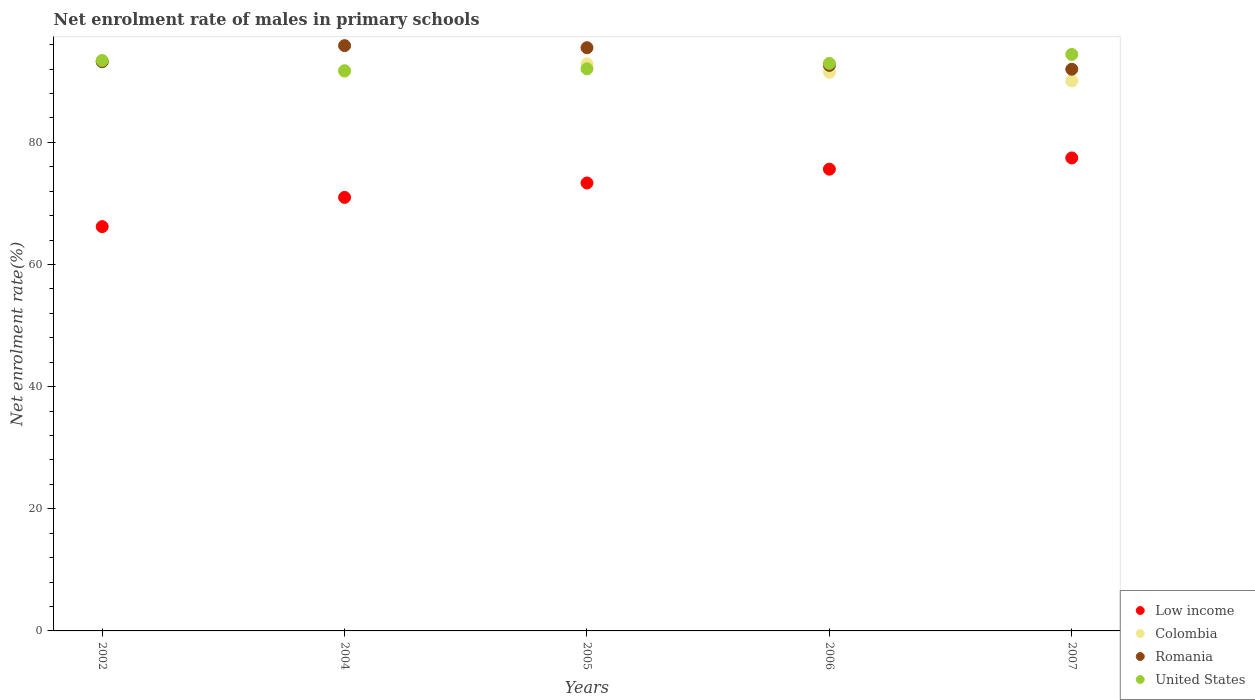Is the number of dotlines equal to the number of legend labels?
Make the answer very short. Yes. What is the net enrolment rate of males in primary schools in United States in 2007?
Offer a very short reply. 94.41. Across all years, what is the maximum net enrolment rate of males in primary schools in Colombia?
Offer a very short reply. 93.23. Across all years, what is the minimum net enrolment rate of males in primary schools in Colombia?
Keep it short and to the point. 90.07. In which year was the net enrolment rate of males in primary schools in Romania maximum?
Your response must be concise. 2004. What is the total net enrolment rate of males in primary schools in Low income in the graph?
Keep it short and to the point. 363.62. What is the difference between the net enrolment rate of males in primary schools in United States in 2004 and that in 2006?
Keep it short and to the point. -1.2. What is the difference between the net enrolment rate of males in primary schools in Colombia in 2004 and the net enrolment rate of males in primary schools in Romania in 2005?
Offer a very short reply. -3.9. What is the average net enrolment rate of males in primary schools in United States per year?
Your response must be concise. 92.91. In the year 2002, what is the difference between the net enrolment rate of males in primary schools in Colombia and net enrolment rate of males in primary schools in United States?
Make the answer very short. -0.18. In how many years, is the net enrolment rate of males in primary schools in United States greater than 12 %?
Keep it short and to the point. 5. What is the ratio of the net enrolment rate of males in primary schools in United States in 2002 to that in 2007?
Your response must be concise. 0.99. Is the net enrolment rate of males in primary schools in Romania in 2005 less than that in 2006?
Make the answer very short. No. What is the difference between the highest and the second highest net enrolment rate of males in primary schools in Romania?
Make the answer very short. 0.34. What is the difference between the highest and the lowest net enrolment rate of males in primary schools in Colombia?
Offer a very short reply. 3.16. In how many years, is the net enrolment rate of males in primary schools in Low income greater than the average net enrolment rate of males in primary schools in Low income taken over all years?
Keep it short and to the point. 3. Is it the case that in every year, the sum of the net enrolment rate of males in primary schools in Colombia and net enrolment rate of males in primary schools in United States  is greater than the net enrolment rate of males in primary schools in Low income?
Provide a succinct answer. Yes. Is the net enrolment rate of males in primary schools in Colombia strictly greater than the net enrolment rate of males in primary schools in Romania over the years?
Your answer should be very brief. No. Is the net enrolment rate of males in primary schools in United States strictly less than the net enrolment rate of males in primary schools in Low income over the years?
Offer a very short reply. No. How many dotlines are there?
Offer a terse response. 4. How many years are there in the graph?
Give a very brief answer. 5. What is the difference between two consecutive major ticks on the Y-axis?
Provide a short and direct response. 20. Does the graph contain any zero values?
Give a very brief answer. No. Does the graph contain grids?
Your response must be concise. No. Where does the legend appear in the graph?
Give a very brief answer. Bottom right. What is the title of the graph?
Your answer should be compact. Net enrolment rate of males in primary schools. Does "Mali" appear as one of the legend labels in the graph?
Keep it short and to the point. No. What is the label or title of the X-axis?
Keep it short and to the point. Years. What is the label or title of the Y-axis?
Make the answer very short. Net enrolment rate(%). What is the Net enrolment rate(%) of Low income in 2002?
Your answer should be very brief. 66.21. What is the Net enrolment rate(%) of Colombia in 2002?
Provide a short and direct response. 93.23. What is the Net enrolment rate(%) in Romania in 2002?
Provide a short and direct response. 93.21. What is the Net enrolment rate(%) of United States in 2002?
Keep it short and to the point. 93.41. What is the Net enrolment rate(%) of Low income in 2004?
Your answer should be compact. 70.99. What is the Net enrolment rate(%) in Colombia in 2004?
Provide a short and direct response. 91.61. What is the Net enrolment rate(%) in Romania in 2004?
Make the answer very short. 95.85. What is the Net enrolment rate(%) of United States in 2004?
Your response must be concise. 91.74. What is the Net enrolment rate(%) in Low income in 2005?
Keep it short and to the point. 73.35. What is the Net enrolment rate(%) in Colombia in 2005?
Provide a short and direct response. 92.86. What is the Net enrolment rate(%) in Romania in 2005?
Make the answer very short. 95.51. What is the Net enrolment rate(%) in United States in 2005?
Provide a succinct answer. 92.05. What is the Net enrolment rate(%) in Low income in 2006?
Make the answer very short. 75.61. What is the Net enrolment rate(%) in Colombia in 2006?
Provide a succinct answer. 91.48. What is the Net enrolment rate(%) in Romania in 2006?
Your answer should be compact. 92.61. What is the Net enrolment rate(%) in United States in 2006?
Give a very brief answer. 92.94. What is the Net enrolment rate(%) of Low income in 2007?
Your answer should be very brief. 77.46. What is the Net enrolment rate(%) of Colombia in 2007?
Your response must be concise. 90.07. What is the Net enrolment rate(%) in Romania in 2007?
Provide a succinct answer. 91.98. What is the Net enrolment rate(%) of United States in 2007?
Make the answer very short. 94.41. Across all years, what is the maximum Net enrolment rate(%) of Low income?
Make the answer very short. 77.46. Across all years, what is the maximum Net enrolment rate(%) in Colombia?
Ensure brevity in your answer.  93.23. Across all years, what is the maximum Net enrolment rate(%) in Romania?
Keep it short and to the point. 95.85. Across all years, what is the maximum Net enrolment rate(%) in United States?
Keep it short and to the point. 94.41. Across all years, what is the minimum Net enrolment rate(%) in Low income?
Offer a very short reply. 66.21. Across all years, what is the minimum Net enrolment rate(%) in Colombia?
Your answer should be compact. 90.07. Across all years, what is the minimum Net enrolment rate(%) of Romania?
Your response must be concise. 91.98. Across all years, what is the minimum Net enrolment rate(%) of United States?
Offer a very short reply. 91.74. What is the total Net enrolment rate(%) in Low income in the graph?
Make the answer very short. 363.62. What is the total Net enrolment rate(%) in Colombia in the graph?
Give a very brief answer. 459.25. What is the total Net enrolment rate(%) of Romania in the graph?
Your answer should be compact. 469.16. What is the total Net enrolment rate(%) of United States in the graph?
Your answer should be compact. 464.55. What is the difference between the Net enrolment rate(%) in Low income in 2002 and that in 2004?
Your response must be concise. -4.79. What is the difference between the Net enrolment rate(%) in Colombia in 2002 and that in 2004?
Make the answer very short. 1.62. What is the difference between the Net enrolment rate(%) in Romania in 2002 and that in 2004?
Provide a short and direct response. -2.63. What is the difference between the Net enrolment rate(%) of United States in 2002 and that in 2004?
Ensure brevity in your answer.  1.67. What is the difference between the Net enrolment rate(%) of Low income in 2002 and that in 2005?
Provide a short and direct response. -7.15. What is the difference between the Net enrolment rate(%) in Colombia in 2002 and that in 2005?
Provide a succinct answer. 0.37. What is the difference between the Net enrolment rate(%) in Romania in 2002 and that in 2005?
Your answer should be compact. -2.29. What is the difference between the Net enrolment rate(%) of United States in 2002 and that in 2005?
Keep it short and to the point. 1.36. What is the difference between the Net enrolment rate(%) of Low income in 2002 and that in 2006?
Your answer should be compact. -9.41. What is the difference between the Net enrolment rate(%) of Colombia in 2002 and that in 2006?
Make the answer very short. 1.75. What is the difference between the Net enrolment rate(%) of Romania in 2002 and that in 2006?
Provide a succinct answer. 0.6. What is the difference between the Net enrolment rate(%) in United States in 2002 and that in 2006?
Your answer should be very brief. 0.47. What is the difference between the Net enrolment rate(%) in Low income in 2002 and that in 2007?
Provide a succinct answer. -11.25. What is the difference between the Net enrolment rate(%) in Colombia in 2002 and that in 2007?
Make the answer very short. 3.16. What is the difference between the Net enrolment rate(%) in Romania in 2002 and that in 2007?
Offer a terse response. 1.24. What is the difference between the Net enrolment rate(%) in United States in 2002 and that in 2007?
Offer a very short reply. -0.99. What is the difference between the Net enrolment rate(%) of Low income in 2004 and that in 2005?
Provide a short and direct response. -2.36. What is the difference between the Net enrolment rate(%) of Colombia in 2004 and that in 2005?
Provide a short and direct response. -1.26. What is the difference between the Net enrolment rate(%) in Romania in 2004 and that in 2005?
Offer a terse response. 0.34. What is the difference between the Net enrolment rate(%) in United States in 2004 and that in 2005?
Make the answer very short. -0.31. What is the difference between the Net enrolment rate(%) of Low income in 2004 and that in 2006?
Provide a short and direct response. -4.62. What is the difference between the Net enrolment rate(%) in Colombia in 2004 and that in 2006?
Give a very brief answer. 0.12. What is the difference between the Net enrolment rate(%) of Romania in 2004 and that in 2006?
Give a very brief answer. 3.24. What is the difference between the Net enrolment rate(%) in United States in 2004 and that in 2006?
Your response must be concise. -1.2. What is the difference between the Net enrolment rate(%) of Low income in 2004 and that in 2007?
Your answer should be compact. -6.46. What is the difference between the Net enrolment rate(%) in Colombia in 2004 and that in 2007?
Offer a terse response. 1.54. What is the difference between the Net enrolment rate(%) of Romania in 2004 and that in 2007?
Offer a very short reply. 3.87. What is the difference between the Net enrolment rate(%) of United States in 2004 and that in 2007?
Make the answer very short. -2.67. What is the difference between the Net enrolment rate(%) in Low income in 2005 and that in 2006?
Give a very brief answer. -2.26. What is the difference between the Net enrolment rate(%) in Colombia in 2005 and that in 2006?
Provide a short and direct response. 1.38. What is the difference between the Net enrolment rate(%) in Romania in 2005 and that in 2006?
Your answer should be very brief. 2.9. What is the difference between the Net enrolment rate(%) in United States in 2005 and that in 2006?
Your response must be concise. -0.89. What is the difference between the Net enrolment rate(%) in Low income in 2005 and that in 2007?
Make the answer very short. -4.1. What is the difference between the Net enrolment rate(%) in Colombia in 2005 and that in 2007?
Offer a very short reply. 2.79. What is the difference between the Net enrolment rate(%) in Romania in 2005 and that in 2007?
Offer a terse response. 3.53. What is the difference between the Net enrolment rate(%) of United States in 2005 and that in 2007?
Give a very brief answer. -2.36. What is the difference between the Net enrolment rate(%) of Low income in 2006 and that in 2007?
Give a very brief answer. -1.84. What is the difference between the Net enrolment rate(%) in Colombia in 2006 and that in 2007?
Make the answer very short. 1.41. What is the difference between the Net enrolment rate(%) in Romania in 2006 and that in 2007?
Ensure brevity in your answer.  0.63. What is the difference between the Net enrolment rate(%) in United States in 2006 and that in 2007?
Provide a succinct answer. -1.47. What is the difference between the Net enrolment rate(%) of Low income in 2002 and the Net enrolment rate(%) of Colombia in 2004?
Keep it short and to the point. -25.4. What is the difference between the Net enrolment rate(%) of Low income in 2002 and the Net enrolment rate(%) of Romania in 2004?
Keep it short and to the point. -29.64. What is the difference between the Net enrolment rate(%) of Low income in 2002 and the Net enrolment rate(%) of United States in 2004?
Offer a terse response. -25.53. What is the difference between the Net enrolment rate(%) of Colombia in 2002 and the Net enrolment rate(%) of Romania in 2004?
Offer a terse response. -2.62. What is the difference between the Net enrolment rate(%) of Colombia in 2002 and the Net enrolment rate(%) of United States in 2004?
Offer a very short reply. 1.49. What is the difference between the Net enrolment rate(%) in Romania in 2002 and the Net enrolment rate(%) in United States in 2004?
Offer a terse response. 1.47. What is the difference between the Net enrolment rate(%) in Low income in 2002 and the Net enrolment rate(%) in Colombia in 2005?
Your answer should be compact. -26.66. What is the difference between the Net enrolment rate(%) of Low income in 2002 and the Net enrolment rate(%) of Romania in 2005?
Your response must be concise. -29.3. What is the difference between the Net enrolment rate(%) of Low income in 2002 and the Net enrolment rate(%) of United States in 2005?
Give a very brief answer. -25.84. What is the difference between the Net enrolment rate(%) in Colombia in 2002 and the Net enrolment rate(%) in Romania in 2005?
Your response must be concise. -2.28. What is the difference between the Net enrolment rate(%) of Colombia in 2002 and the Net enrolment rate(%) of United States in 2005?
Provide a succinct answer. 1.18. What is the difference between the Net enrolment rate(%) of Romania in 2002 and the Net enrolment rate(%) of United States in 2005?
Ensure brevity in your answer.  1.17. What is the difference between the Net enrolment rate(%) of Low income in 2002 and the Net enrolment rate(%) of Colombia in 2006?
Your answer should be very brief. -25.28. What is the difference between the Net enrolment rate(%) of Low income in 2002 and the Net enrolment rate(%) of Romania in 2006?
Your answer should be compact. -26.4. What is the difference between the Net enrolment rate(%) in Low income in 2002 and the Net enrolment rate(%) in United States in 2006?
Your answer should be compact. -26.73. What is the difference between the Net enrolment rate(%) of Colombia in 2002 and the Net enrolment rate(%) of Romania in 2006?
Provide a short and direct response. 0.62. What is the difference between the Net enrolment rate(%) in Colombia in 2002 and the Net enrolment rate(%) in United States in 2006?
Offer a very short reply. 0.29. What is the difference between the Net enrolment rate(%) of Romania in 2002 and the Net enrolment rate(%) of United States in 2006?
Ensure brevity in your answer.  0.27. What is the difference between the Net enrolment rate(%) in Low income in 2002 and the Net enrolment rate(%) in Colombia in 2007?
Your answer should be compact. -23.86. What is the difference between the Net enrolment rate(%) in Low income in 2002 and the Net enrolment rate(%) in Romania in 2007?
Give a very brief answer. -25.77. What is the difference between the Net enrolment rate(%) of Low income in 2002 and the Net enrolment rate(%) of United States in 2007?
Offer a terse response. -28.2. What is the difference between the Net enrolment rate(%) of Colombia in 2002 and the Net enrolment rate(%) of Romania in 2007?
Give a very brief answer. 1.25. What is the difference between the Net enrolment rate(%) in Colombia in 2002 and the Net enrolment rate(%) in United States in 2007?
Keep it short and to the point. -1.18. What is the difference between the Net enrolment rate(%) in Romania in 2002 and the Net enrolment rate(%) in United States in 2007?
Provide a short and direct response. -1.19. What is the difference between the Net enrolment rate(%) in Low income in 2004 and the Net enrolment rate(%) in Colombia in 2005?
Make the answer very short. -21.87. What is the difference between the Net enrolment rate(%) of Low income in 2004 and the Net enrolment rate(%) of Romania in 2005?
Your answer should be compact. -24.51. What is the difference between the Net enrolment rate(%) in Low income in 2004 and the Net enrolment rate(%) in United States in 2005?
Your answer should be compact. -21.06. What is the difference between the Net enrolment rate(%) in Colombia in 2004 and the Net enrolment rate(%) in Romania in 2005?
Give a very brief answer. -3.9. What is the difference between the Net enrolment rate(%) of Colombia in 2004 and the Net enrolment rate(%) of United States in 2005?
Make the answer very short. -0.44. What is the difference between the Net enrolment rate(%) of Romania in 2004 and the Net enrolment rate(%) of United States in 2005?
Your answer should be very brief. 3.8. What is the difference between the Net enrolment rate(%) in Low income in 2004 and the Net enrolment rate(%) in Colombia in 2006?
Your answer should be very brief. -20.49. What is the difference between the Net enrolment rate(%) in Low income in 2004 and the Net enrolment rate(%) in Romania in 2006?
Give a very brief answer. -21.62. What is the difference between the Net enrolment rate(%) in Low income in 2004 and the Net enrolment rate(%) in United States in 2006?
Make the answer very short. -21.95. What is the difference between the Net enrolment rate(%) in Colombia in 2004 and the Net enrolment rate(%) in Romania in 2006?
Ensure brevity in your answer.  -1. What is the difference between the Net enrolment rate(%) in Colombia in 2004 and the Net enrolment rate(%) in United States in 2006?
Your answer should be very brief. -1.33. What is the difference between the Net enrolment rate(%) of Romania in 2004 and the Net enrolment rate(%) of United States in 2006?
Your answer should be compact. 2.91. What is the difference between the Net enrolment rate(%) in Low income in 2004 and the Net enrolment rate(%) in Colombia in 2007?
Offer a very short reply. -19.08. What is the difference between the Net enrolment rate(%) of Low income in 2004 and the Net enrolment rate(%) of Romania in 2007?
Make the answer very short. -20.99. What is the difference between the Net enrolment rate(%) of Low income in 2004 and the Net enrolment rate(%) of United States in 2007?
Offer a terse response. -23.42. What is the difference between the Net enrolment rate(%) of Colombia in 2004 and the Net enrolment rate(%) of Romania in 2007?
Your answer should be very brief. -0.37. What is the difference between the Net enrolment rate(%) in Colombia in 2004 and the Net enrolment rate(%) in United States in 2007?
Give a very brief answer. -2.8. What is the difference between the Net enrolment rate(%) of Romania in 2004 and the Net enrolment rate(%) of United States in 2007?
Give a very brief answer. 1.44. What is the difference between the Net enrolment rate(%) in Low income in 2005 and the Net enrolment rate(%) in Colombia in 2006?
Offer a terse response. -18.13. What is the difference between the Net enrolment rate(%) of Low income in 2005 and the Net enrolment rate(%) of Romania in 2006?
Your answer should be very brief. -19.26. What is the difference between the Net enrolment rate(%) in Low income in 2005 and the Net enrolment rate(%) in United States in 2006?
Make the answer very short. -19.59. What is the difference between the Net enrolment rate(%) of Colombia in 2005 and the Net enrolment rate(%) of Romania in 2006?
Give a very brief answer. 0.25. What is the difference between the Net enrolment rate(%) in Colombia in 2005 and the Net enrolment rate(%) in United States in 2006?
Your answer should be very brief. -0.08. What is the difference between the Net enrolment rate(%) in Romania in 2005 and the Net enrolment rate(%) in United States in 2006?
Your answer should be very brief. 2.57. What is the difference between the Net enrolment rate(%) of Low income in 2005 and the Net enrolment rate(%) of Colombia in 2007?
Provide a succinct answer. -16.72. What is the difference between the Net enrolment rate(%) of Low income in 2005 and the Net enrolment rate(%) of Romania in 2007?
Make the answer very short. -18.63. What is the difference between the Net enrolment rate(%) in Low income in 2005 and the Net enrolment rate(%) in United States in 2007?
Provide a succinct answer. -21.05. What is the difference between the Net enrolment rate(%) in Colombia in 2005 and the Net enrolment rate(%) in Romania in 2007?
Offer a terse response. 0.88. What is the difference between the Net enrolment rate(%) in Colombia in 2005 and the Net enrolment rate(%) in United States in 2007?
Offer a terse response. -1.54. What is the difference between the Net enrolment rate(%) in Romania in 2005 and the Net enrolment rate(%) in United States in 2007?
Ensure brevity in your answer.  1.1. What is the difference between the Net enrolment rate(%) of Low income in 2006 and the Net enrolment rate(%) of Colombia in 2007?
Your response must be concise. -14.46. What is the difference between the Net enrolment rate(%) in Low income in 2006 and the Net enrolment rate(%) in Romania in 2007?
Your response must be concise. -16.36. What is the difference between the Net enrolment rate(%) in Low income in 2006 and the Net enrolment rate(%) in United States in 2007?
Your response must be concise. -18.79. What is the difference between the Net enrolment rate(%) of Colombia in 2006 and the Net enrolment rate(%) of Romania in 2007?
Ensure brevity in your answer.  -0.5. What is the difference between the Net enrolment rate(%) in Colombia in 2006 and the Net enrolment rate(%) in United States in 2007?
Ensure brevity in your answer.  -2.92. What is the difference between the Net enrolment rate(%) of Romania in 2006 and the Net enrolment rate(%) of United States in 2007?
Your response must be concise. -1.8. What is the average Net enrolment rate(%) of Low income per year?
Your response must be concise. 72.72. What is the average Net enrolment rate(%) of Colombia per year?
Keep it short and to the point. 91.85. What is the average Net enrolment rate(%) in Romania per year?
Make the answer very short. 93.83. What is the average Net enrolment rate(%) of United States per year?
Provide a short and direct response. 92.91. In the year 2002, what is the difference between the Net enrolment rate(%) in Low income and Net enrolment rate(%) in Colombia?
Offer a very short reply. -27.02. In the year 2002, what is the difference between the Net enrolment rate(%) of Low income and Net enrolment rate(%) of Romania?
Offer a very short reply. -27.01. In the year 2002, what is the difference between the Net enrolment rate(%) in Low income and Net enrolment rate(%) in United States?
Keep it short and to the point. -27.21. In the year 2002, what is the difference between the Net enrolment rate(%) in Colombia and Net enrolment rate(%) in Romania?
Keep it short and to the point. 0.01. In the year 2002, what is the difference between the Net enrolment rate(%) in Colombia and Net enrolment rate(%) in United States?
Keep it short and to the point. -0.18. In the year 2002, what is the difference between the Net enrolment rate(%) of Romania and Net enrolment rate(%) of United States?
Your response must be concise. -0.2. In the year 2004, what is the difference between the Net enrolment rate(%) in Low income and Net enrolment rate(%) in Colombia?
Offer a very short reply. -20.61. In the year 2004, what is the difference between the Net enrolment rate(%) in Low income and Net enrolment rate(%) in Romania?
Provide a short and direct response. -24.85. In the year 2004, what is the difference between the Net enrolment rate(%) of Low income and Net enrolment rate(%) of United States?
Your answer should be very brief. -20.75. In the year 2004, what is the difference between the Net enrolment rate(%) of Colombia and Net enrolment rate(%) of Romania?
Make the answer very short. -4.24. In the year 2004, what is the difference between the Net enrolment rate(%) in Colombia and Net enrolment rate(%) in United States?
Offer a terse response. -0.14. In the year 2004, what is the difference between the Net enrolment rate(%) in Romania and Net enrolment rate(%) in United States?
Offer a very short reply. 4.11. In the year 2005, what is the difference between the Net enrolment rate(%) of Low income and Net enrolment rate(%) of Colombia?
Your answer should be very brief. -19.51. In the year 2005, what is the difference between the Net enrolment rate(%) in Low income and Net enrolment rate(%) in Romania?
Ensure brevity in your answer.  -22.15. In the year 2005, what is the difference between the Net enrolment rate(%) in Low income and Net enrolment rate(%) in United States?
Provide a succinct answer. -18.7. In the year 2005, what is the difference between the Net enrolment rate(%) in Colombia and Net enrolment rate(%) in Romania?
Give a very brief answer. -2.64. In the year 2005, what is the difference between the Net enrolment rate(%) of Colombia and Net enrolment rate(%) of United States?
Provide a succinct answer. 0.81. In the year 2005, what is the difference between the Net enrolment rate(%) in Romania and Net enrolment rate(%) in United States?
Provide a succinct answer. 3.46. In the year 2006, what is the difference between the Net enrolment rate(%) in Low income and Net enrolment rate(%) in Colombia?
Offer a very short reply. -15.87. In the year 2006, what is the difference between the Net enrolment rate(%) of Low income and Net enrolment rate(%) of Romania?
Offer a terse response. -17. In the year 2006, what is the difference between the Net enrolment rate(%) of Low income and Net enrolment rate(%) of United States?
Your response must be concise. -17.33. In the year 2006, what is the difference between the Net enrolment rate(%) of Colombia and Net enrolment rate(%) of Romania?
Keep it short and to the point. -1.13. In the year 2006, what is the difference between the Net enrolment rate(%) of Colombia and Net enrolment rate(%) of United States?
Make the answer very short. -1.46. In the year 2006, what is the difference between the Net enrolment rate(%) of Romania and Net enrolment rate(%) of United States?
Keep it short and to the point. -0.33. In the year 2007, what is the difference between the Net enrolment rate(%) in Low income and Net enrolment rate(%) in Colombia?
Your answer should be compact. -12.61. In the year 2007, what is the difference between the Net enrolment rate(%) in Low income and Net enrolment rate(%) in Romania?
Offer a terse response. -14.52. In the year 2007, what is the difference between the Net enrolment rate(%) of Low income and Net enrolment rate(%) of United States?
Provide a short and direct response. -16.95. In the year 2007, what is the difference between the Net enrolment rate(%) in Colombia and Net enrolment rate(%) in Romania?
Offer a very short reply. -1.91. In the year 2007, what is the difference between the Net enrolment rate(%) of Colombia and Net enrolment rate(%) of United States?
Provide a short and direct response. -4.34. In the year 2007, what is the difference between the Net enrolment rate(%) of Romania and Net enrolment rate(%) of United States?
Ensure brevity in your answer.  -2.43. What is the ratio of the Net enrolment rate(%) in Low income in 2002 to that in 2004?
Your answer should be very brief. 0.93. What is the ratio of the Net enrolment rate(%) of Colombia in 2002 to that in 2004?
Ensure brevity in your answer.  1.02. What is the ratio of the Net enrolment rate(%) of Romania in 2002 to that in 2004?
Offer a very short reply. 0.97. What is the ratio of the Net enrolment rate(%) of United States in 2002 to that in 2004?
Ensure brevity in your answer.  1.02. What is the ratio of the Net enrolment rate(%) in Low income in 2002 to that in 2005?
Make the answer very short. 0.9. What is the ratio of the Net enrolment rate(%) of Colombia in 2002 to that in 2005?
Your answer should be compact. 1. What is the ratio of the Net enrolment rate(%) of United States in 2002 to that in 2005?
Ensure brevity in your answer.  1.01. What is the ratio of the Net enrolment rate(%) in Low income in 2002 to that in 2006?
Your answer should be compact. 0.88. What is the ratio of the Net enrolment rate(%) in Colombia in 2002 to that in 2006?
Make the answer very short. 1.02. What is the ratio of the Net enrolment rate(%) in Romania in 2002 to that in 2006?
Offer a very short reply. 1.01. What is the ratio of the Net enrolment rate(%) of United States in 2002 to that in 2006?
Keep it short and to the point. 1.01. What is the ratio of the Net enrolment rate(%) in Low income in 2002 to that in 2007?
Offer a very short reply. 0.85. What is the ratio of the Net enrolment rate(%) in Colombia in 2002 to that in 2007?
Your response must be concise. 1.04. What is the ratio of the Net enrolment rate(%) of Romania in 2002 to that in 2007?
Ensure brevity in your answer.  1.01. What is the ratio of the Net enrolment rate(%) in Low income in 2004 to that in 2005?
Make the answer very short. 0.97. What is the ratio of the Net enrolment rate(%) of Colombia in 2004 to that in 2005?
Your answer should be compact. 0.99. What is the ratio of the Net enrolment rate(%) of United States in 2004 to that in 2005?
Give a very brief answer. 1. What is the ratio of the Net enrolment rate(%) of Low income in 2004 to that in 2006?
Keep it short and to the point. 0.94. What is the ratio of the Net enrolment rate(%) of Romania in 2004 to that in 2006?
Your response must be concise. 1.03. What is the ratio of the Net enrolment rate(%) in United States in 2004 to that in 2006?
Provide a short and direct response. 0.99. What is the ratio of the Net enrolment rate(%) in Low income in 2004 to that in 2007?
Give a very brief answer. 0.92. What is the ratio of the Net enrolment rate(%) in Colombia in 2004 to that in 2007?
Ensure brevity in your answer.  1.02. What is the ratio of the Net enrolment rate(%) of Romania in 2004 to that in 2007?
Provide a succinct answer. 1.04. What is the ratio of the Net enrolment rate(%) of United States in 2004 to that in 2007?
Provide a succinct answer. 0.97. What is the ratio of the Net enrolment rate(%) of Low income in 2005 to that in 2006?
Your response must be concise. 0.97. What is the ratio of the Net enrolment rate(%) of Colombia in 2005 to that in 2006?
Keep it short and to the point. 1.02. What is the ratio of the Net enrolment rate(%) in Romania in 2005 to that in 2006?
Provide a short and direct response. 1.03. What is the ratio of the Net enrolment rate(%) in Low income in 2005 to that in 2007?
Give a very brief answer. 0.95. What is the ratio of the Net enrolment rate(%) of Colombia in 2005 to that in 2007?
Offer a very short reply. 1.03. What is the ratio of the Net enrolment rate(%) of Romania in 2005 to that in 2007?
Make the answer very short. 1.04. What is the ratio of the Net enrolment rate(%) in United States in 2005 to that in 2007?
Offer a very short reply. 0.97. What is the ratio of the Net enrolment rate(%) of Low income in 2006 to that in 2007?
Give a very brief answer. 0.98. What is the ratio of the Net enrolment rate(%) in Colombia in 2006 to that in 2007?
Keep it short and to the point. 1.02. What is the ratio of the Net enrolment rate(%) in Romania in 2006 to that in 2007?
Your answer should be very brief. 1.01. What is the ratio of the Net enrolment rate(%) of United States in 2006 to that in 2007?
Provide a short and direct response. 0.98. What is the difference between the highest and the second highest Net enrolment rate(%) of Low income?
Make the answer very short. 1.84. What is the difference between the highest and the second highest Net enrolment rate(%) of Colombia?
Offer a terse response. 0.37. What is the difference between the highest and the second highest Net enrolment rate(%) of Romania?
Offer a very short reply. 0.34. What is the difference between the highest and the second highest Net enrolment rate(%) in United States?
Your answer should be compact. 0.99. What is the difference between the highest and the lowest Net enrolment rate(%) of Low income?
Your answer should be compact. 11.25. What is the difference between the highest and the lowest Net enrolment rate(%) of Colombia?
Keep it short and to the point. 3.16. What is the difference between the highest and the lowest Net enrolment rate(%) of Romania?
Give a very brief answer. 3.87. What is the difference between the highest and the lowest Net enrolment rate(%) of United States?
Make the answer very short. 2.67. 